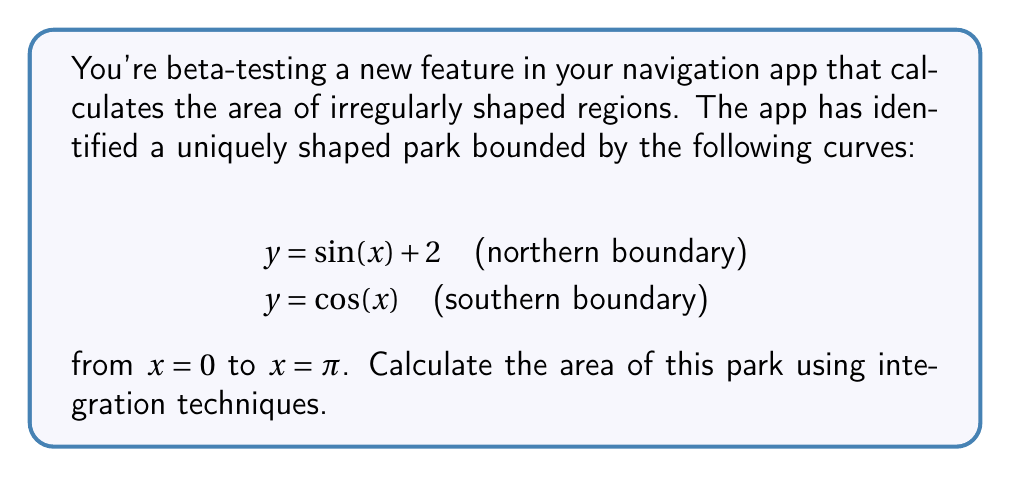Can you answer this question? To find the area of the irregularly shaped park, we need to integrate the difference between the upper and lower boundary functions over the given interval. Let's approach this step-by-step:

1) The area between two curves is given by the formula:

   $$A = \int_a^b [f(x) - g(x)] dx$$

   where $f(x)$ is the upper curve and $g(x)$ is the lower curve.

2) In this case:
   $f(x) = \sin(x) + 2$ (upper curve)
   $g(x) = \cos(x)$ (lower curve)
   $a = 0$ and $b = \pi$ (interval)

3) Substituting into the formula:

   $$A = \int_0^\pi [(\sin(x) + 2) - \cos(x)] dx$$

4) Simplify inside the integral:

   $$A = \int_0^\pi [\sin(x) - \cos(x) + 2] dx$$

5) Integrate each term:

   $$A = [-\cos(x) - \sin(x) + 2x]_0^\pi$$

6) Evaluate the antiderivative at the limits:

   $$A = [-\cos(\pi) - \sin(\pi) + 2\pi] - [-\cos(0) - \sin(0) + 2(0)]$$

7) Simplify:

   $$A = [1 - 0 + 2\pi] - [-1 - 0 + 0] = 1 + 2\pi + 1 = 2\pi + 2$$

Therefore, the area of the park is $2\pi + 2$ square units.
Answer: $2\pi + 2$ square units 